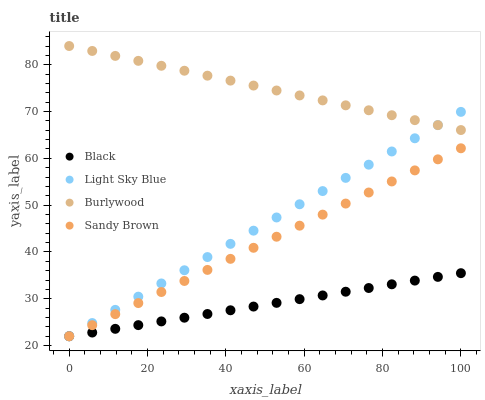Does Black have the minimum area under the curve?
Answer yes or no. Yes. Does Burlywood have the maximum area under the curve?
Answer yes or no. Yes. Does Sandy Brown have the minimum area under the curve?
Answer yes or no. No. Does Sandy Brown have the maximum area under the curve?
Answer yes or no. No. Is Black the smoothest?
Answer yes or no. Yes. Is Burlywood the roughest?
Answer yes or no. Yes. Is Sandy Brown the smoothest?
Answer yes or no. No. Is Sandy Brown the roughest?
Answer yes or no. No. Does Sandy Brown have the lowest value?
Answer yes or no. Yes. Does Burlywood have the highest value?
Answer yes or no. Yes. Does Sandy Brown have the highest value?
Answer yes or no. No. Is Sandy Brown less than Burlywood?
Answer yes or no. Yes. Is Burlywood greater than Sandy Brown?
Answer yes or no. Yes. Does Light Sky Blue intersect Burlywood?
Answer yes or no. Yes. Is Light Sky Blue less than Burlywood?
Answer yes or no. No. Is Light Sky Blue greater than Burlywood?
Answer yes or no. No. Does Sandy Brown intersect Burlywood?
Answer yes or no. No. 